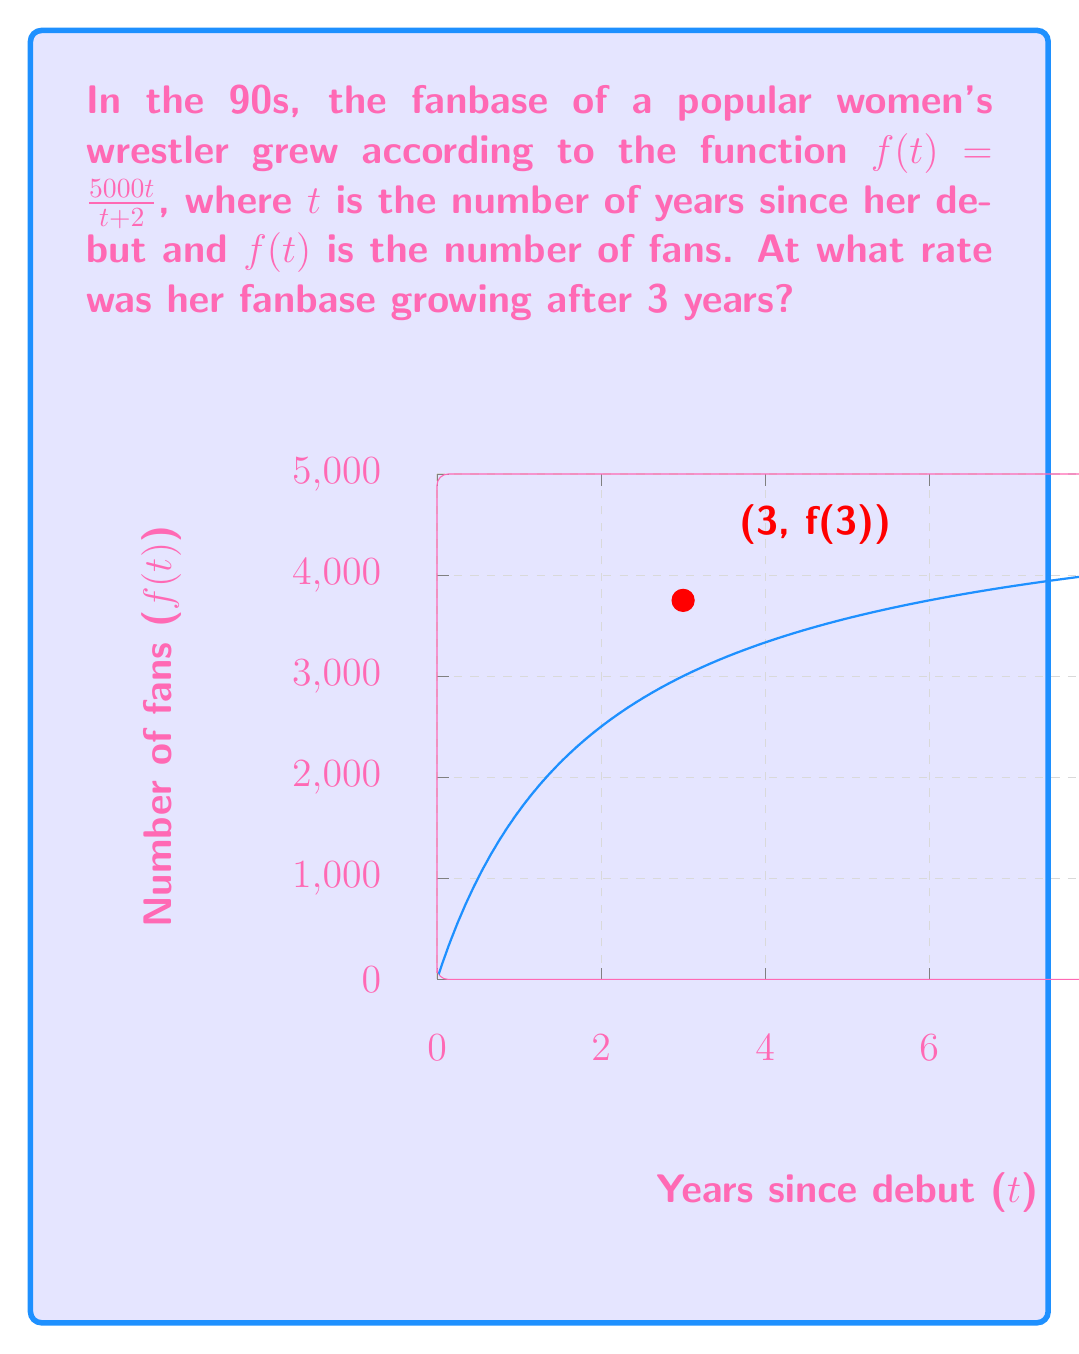Could you help me with this problem? To find the rate at which the fanbase was growing after 3 years, we need to calculate the derivative of the function $f(t)$ and evaluate it at $t=3$. Let's break this down step-by-step:

1) The given function is $f(t) = \frac{5000t}{t+2}$

2) To find the derivative, we use the quotient rule: 
   $\frac{d}{dt}\left(\frac{u}{v}\right) = \frac{v\frac{du}{dt} - u\frac{dv}{dt}}{v^2}$

3) Here, $u = 5000t$ and $v = t+2$
   $\frac{du}{dt} = 5000$ and $\frac{dv}{dt} = 1$

4) Applying the quotient rule:
   $f'(t) = \frac{(t+2)(5000) - 5000t(1)}{(t+2)^2}$

5) Simplifying:
   $f'(t) = \frac{5000t + 10000 - 5000t}{(t+2)^2} = \frac{10000}{(t+2)^2}$

6) Now, we evaluate $f'(3)$:
   $f'(3) = \frac{10000}{(3+2)^2} = \frac{10000}{25} = 400$

Therefore, after 3 years, the fanbase was growing at a rate of 400 fans per year.
Answer: 400 fans/year 